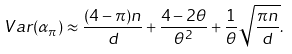<formula> <loc_0><loc_0><loc_500><loc_500>\ V a r ( \alpha _ { \pi } ) \approx \frac { ( 4 - \pi ) n } { d } + \frac { 4 - 2 \theta } { \theta ^ { 2 } } + \frac { 1 } { \theta } \sqrt { \frac { \pi n } { d } } .</formula> 